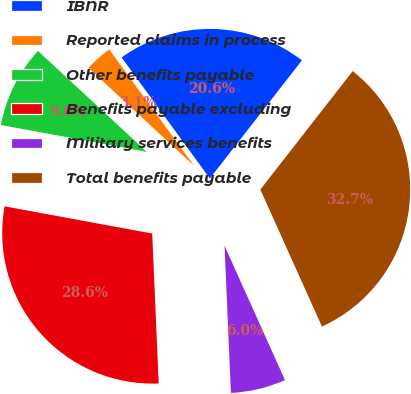Convert chart to OTSL. <chart><loc_0><loc_0><loc_500><loc_500><pie_chart><fcel>IBNR<fcel>Reported claims in process<fcel>Other benefits payable<fcel>Benefits payable excluding<fcel>Military services benefits<fcel>Total benefits payable<nl><fcel>20.57%<fcel>3.07%<fcel>9.0%<fcel>28.59%<fcel>6.04%<fcel>32.73%<nl></chart> 